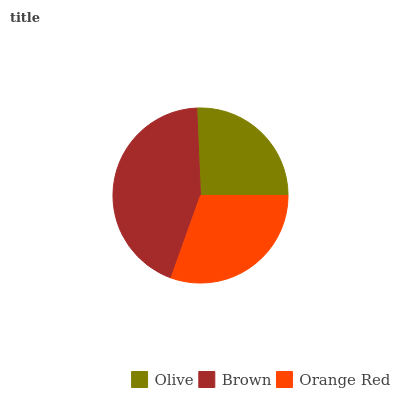Is Olive the minimum?
Answer yes or no. Yes. Is Brown the maximum?
Answer yes or no. Yes. Is Orange Red the minimum?
Answer yes or no. No. Is Orange Red the maximum?
Answer yes or no. No. Is Brown greater than Orange Red?
Answer yes or no. Yes. Is Orange Red less than Brown?
Answer yes or no. Yes. Is Orange Red greater than Brown?
Answer yes or no. No. Is Brown less than Orange Red?
Answer yes or no. No. Is Orange Red the high median?
Answer yes or no. Yes. Is Orange Red the low median?
Answer yes or no. Yes. Is Olive the high median?
Answer yes or no. No. Is Brown the low median?
Answer yes or no. No. 